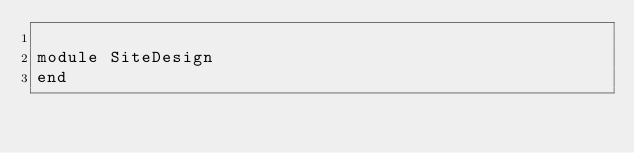<code> <loc_0><loc_0><loc_500><loc_500><_Ruby_>
module SiteDesign
end
</code> 